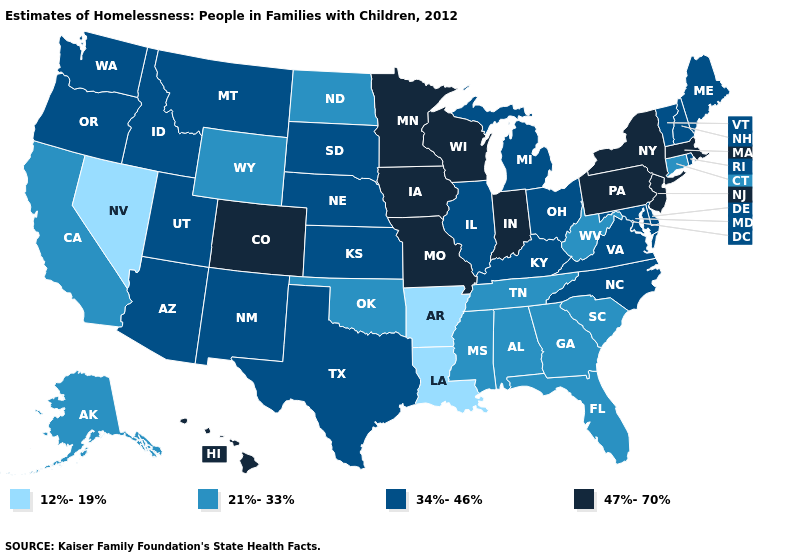What is the highest value in the USA?
Answer briefly. 47%-70%. Does Hawaii have a higher value than Iowa?
Quick response, please. No. Name the states that have a value in the range 34%-46%?
Keep it brief. Arizona, Delaware, Idaho, Illinois, Kansas, Kentucky, Maine, Maryland, Michigan, Montana, Nebraska, New Hampshire, New Mexico, North Carolina, Ohio, Oregon, Rhode Island, South Dakota, Texas, Utah, Vermont, Virginia, Washington. Among the states that border North Carolina , which have the lowest value?
Keep it brief. Georgia, South Carolina, Tennessee. Name the states that have a value in the range 12%-19%?
Quick response, please. Arkansas, Louisiana, Nevada. Is the legend a continuous bar?
Be succinct. No. What is the value of South Carolina?
Concise answer only. 21%-33%. Does West Virginia have the highest value in the South?
Write a very short answer. No. What is the lowest value in the USA?
Give a very brief answer. 12%-19%. What is the highest value in the USA?
Quick response, please. 47%-70%. What is the value of Montana?
Quick response, please. 34%-46%. What is the value of Illinois?
Give a very brief answer. 34%-46%. Which states hav the highest value in the South?
Write a very short answer. Delaware, Kentucky, Maryland, North Carolina, Texas, Virginia. What is the highest value in states that border Montana?
Short answer required. 34%-46%. 